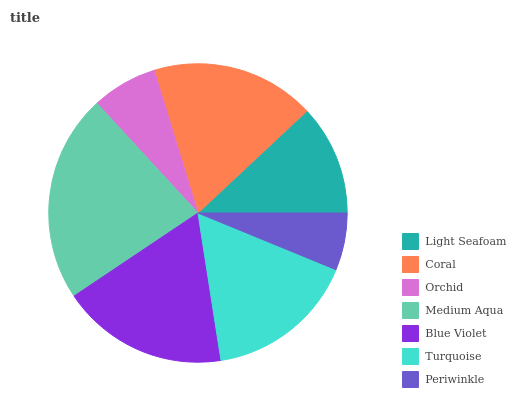Is Periwinkle the minimum?
Answer yes or no. Yes. Is Medium Aqua the maximum?
Answer yes or no. Yes. Is Coral the minimum?
Answer yes or no. No. Is Coral the maximum?
Answer yes or no. No. Is Coral greater than Light Seafoam?
Answer yes or no. Yes. Is Light Seafoam less than Coral?
Answer yes or no. Yes. Is Light Seafoam greater than Coral?
Answer yes or no. No. Is Coral less than Light Seafoam?
Answer yes or no. No. Is Turquoise the high median?
Answer yes or no. Yes. Is Turquoise the low median?
Answer yes or no. Yes. Is Coral the high median?
Answer yes or no. No. Is Orchid the low median?
Answer yes or no. No. 